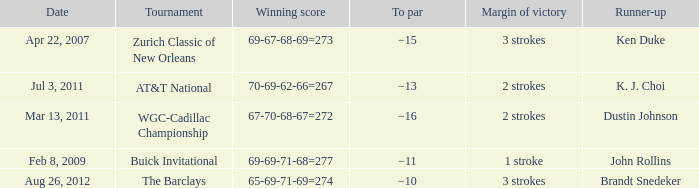What is the date that has a winning score of 67-70-68-67=272? Mar 13, 2011. 